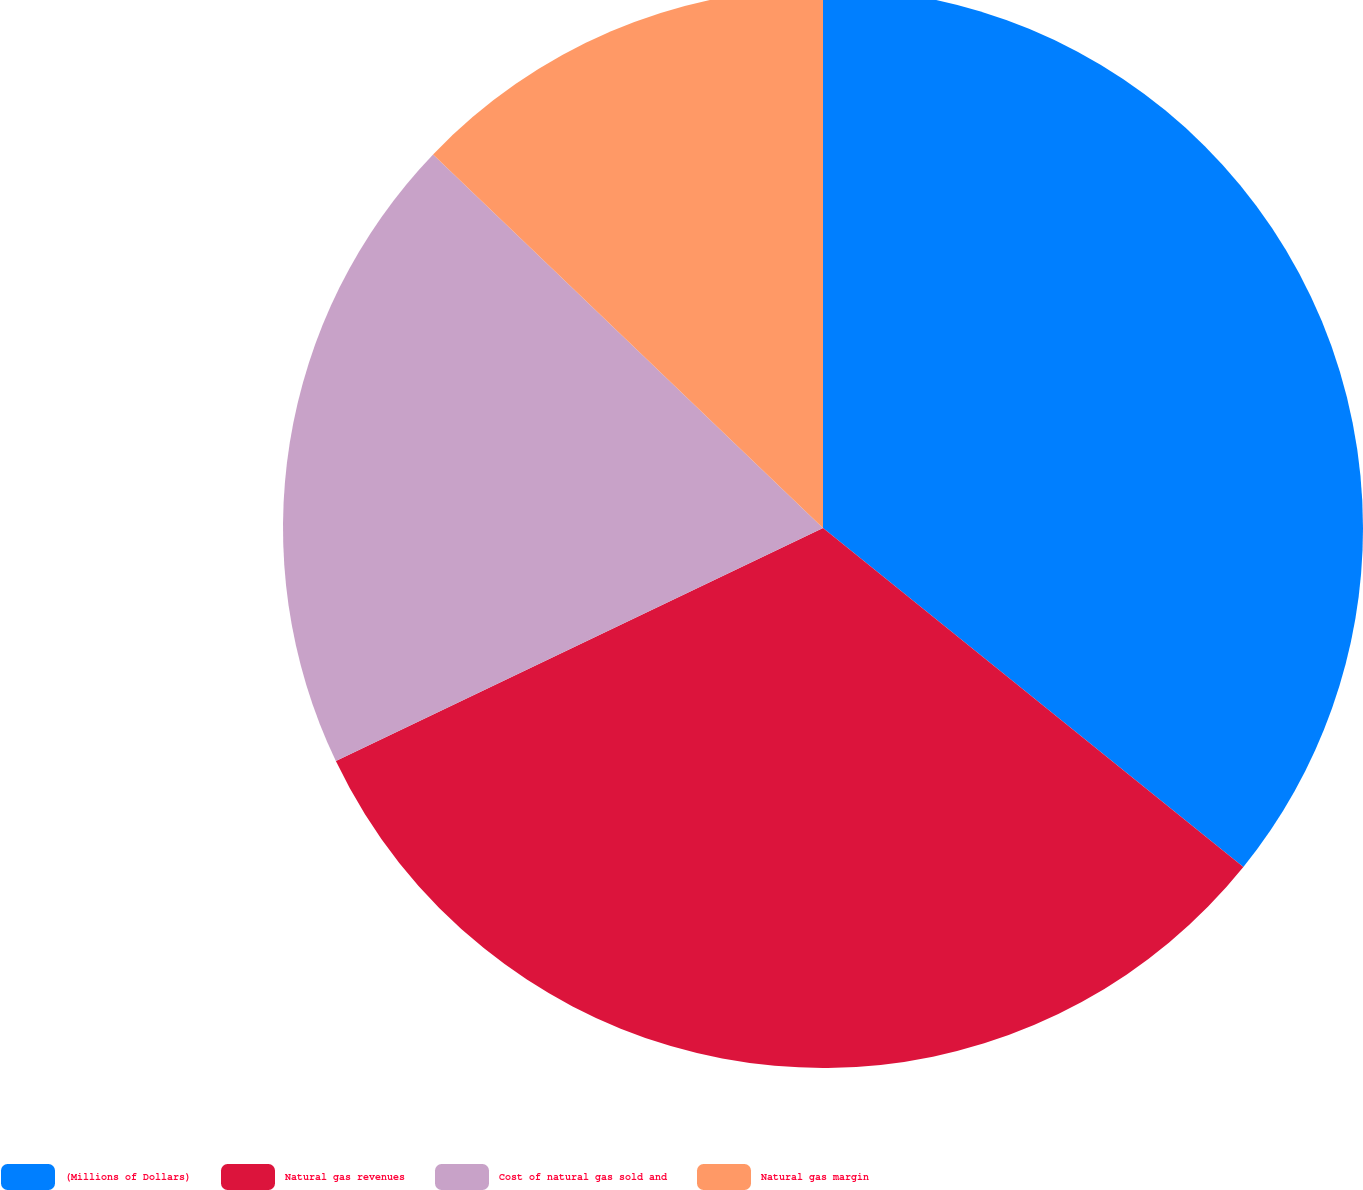<chart> <loc_0><loc_0><loc_500><loc_500><pie_chart><fcel>(Millions of Dollars)<fcel>Natural gas revenues<fcel>Cost of natural gas sold and<fcel>Natural gas margin<nl><fcel>35.8%<fcel>32.1%<fcel>19.26%<fcel>12.84%<nl></chart> 